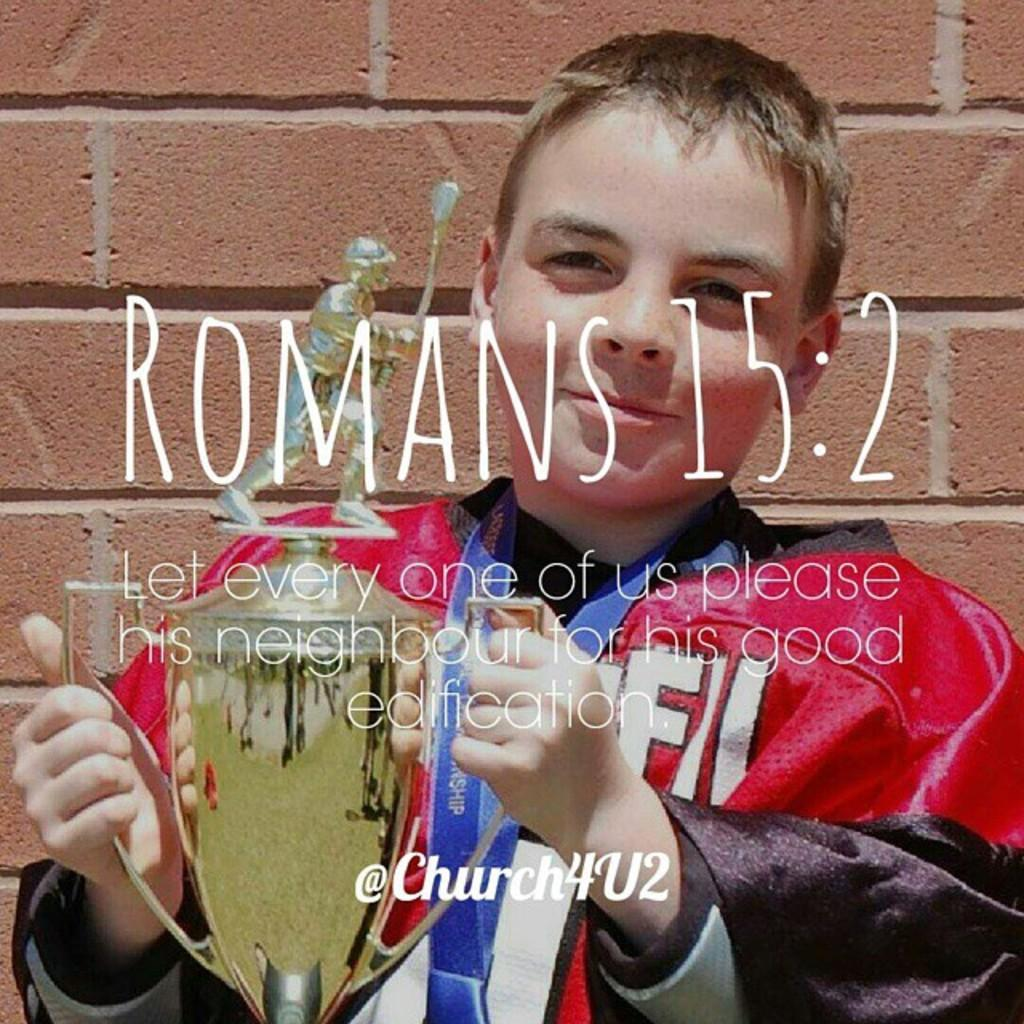<image>
Share a concise interpretation of the image provided. A poster of a child holding a trophy along with a biblical quote from Romans 15:2. 